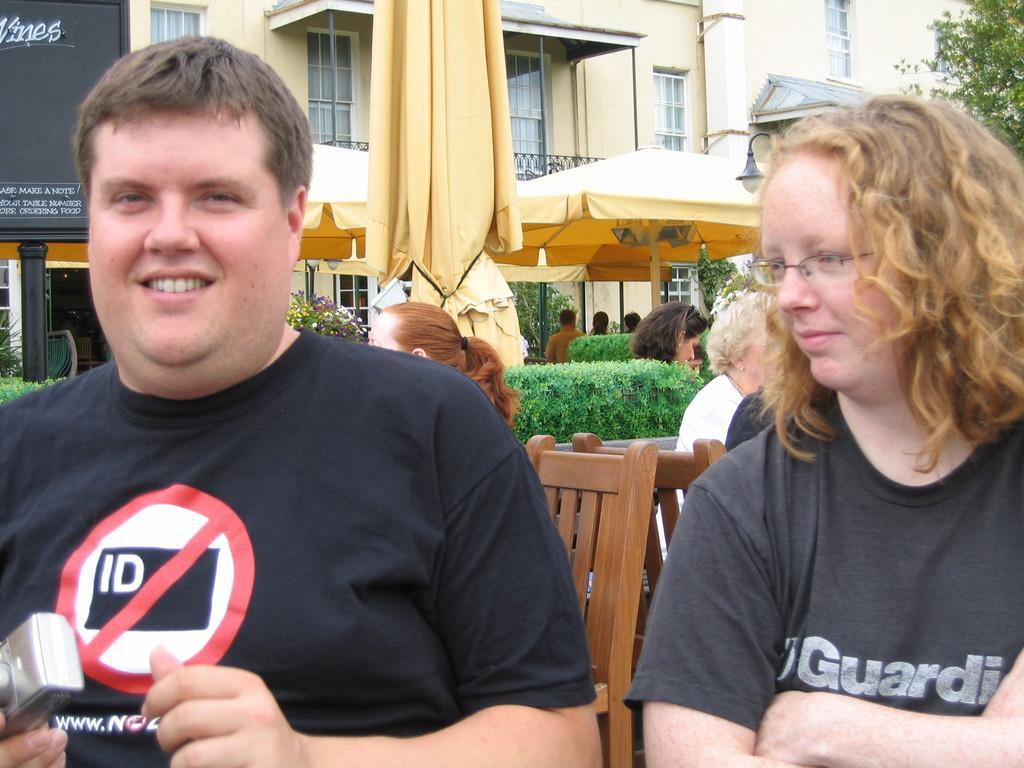<image>
Summarize the visual content of the image. A young man and woman both wearing black t-shirts with his having a "no ID" sign on the front. 